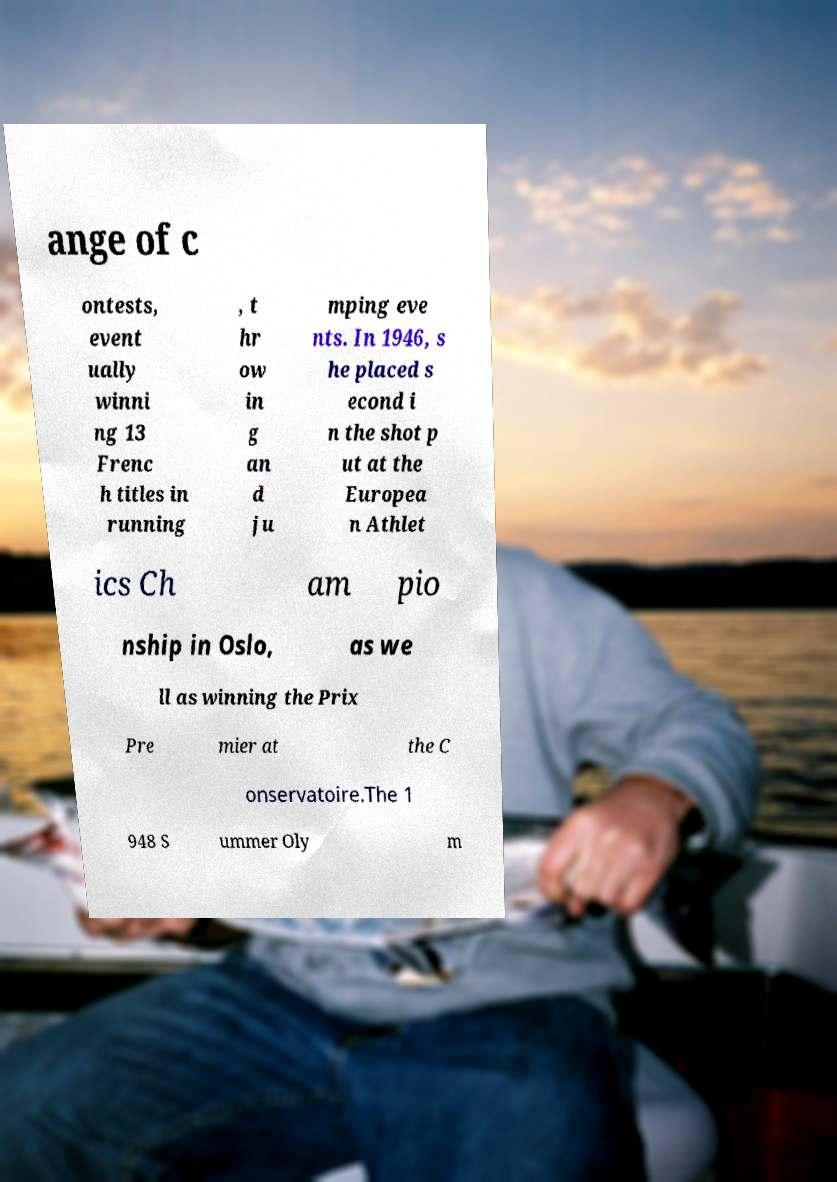Please read and relay the text visible in this image. What does it say? ange of c ontests, event ually winni ng 13 Frenc h titles in running , t hr ow in g an d ju mping eve nts. In 1946, s he placed s econd i n the shot p ut at the Europea n Athlet ics Ch am pio nship in Oslo, as we ll as winning the Prix Pre mier at the C onservatoire.The 1 948 S ummer Oly m 